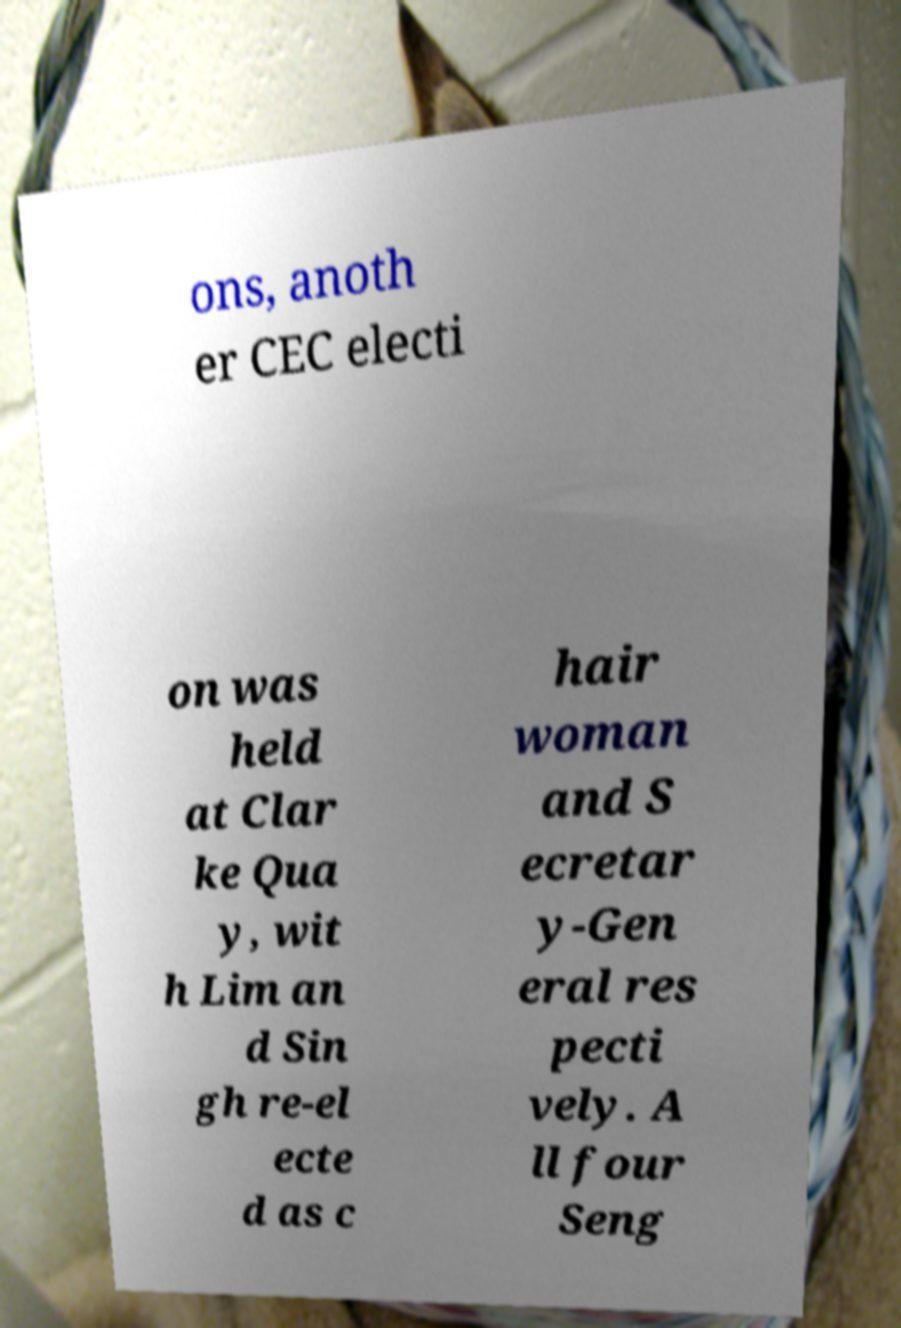Can you read and provide the text displayed in the image?This photo seems to have some interesting text. Can you extract and type it out for me? ons, anoth er CEC electi on was held at Clar ke Qua y, wit h Lim an d Sin gh re-el ecte d as c hair woman and S ecretar y-Gen eral res pecti vely. A ll four Seng 